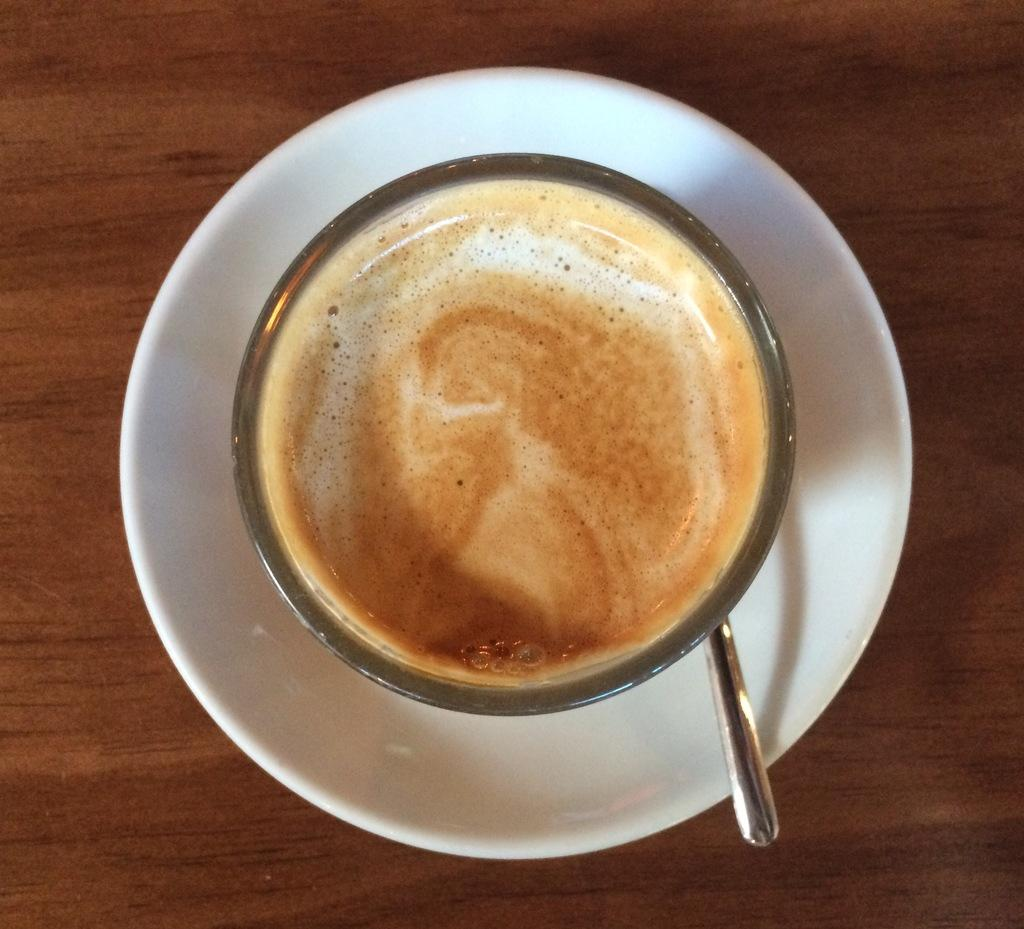What is the main object in the image? There is a coffee cup in the image. What is the coffee cup placed on? There is a saucer in the coffee cup in the image. What utensil is present in the image? There is a spoon in the image. What might the wooden object be used for? The wooden object that looks like a table in the image might be used for placing objects or serving as a surface. What type of order is being processed in the image? There is no indication of an order being processed in the image; it only features a coffee cup, saucer, spoon, and a wooden object that looks like a table. 